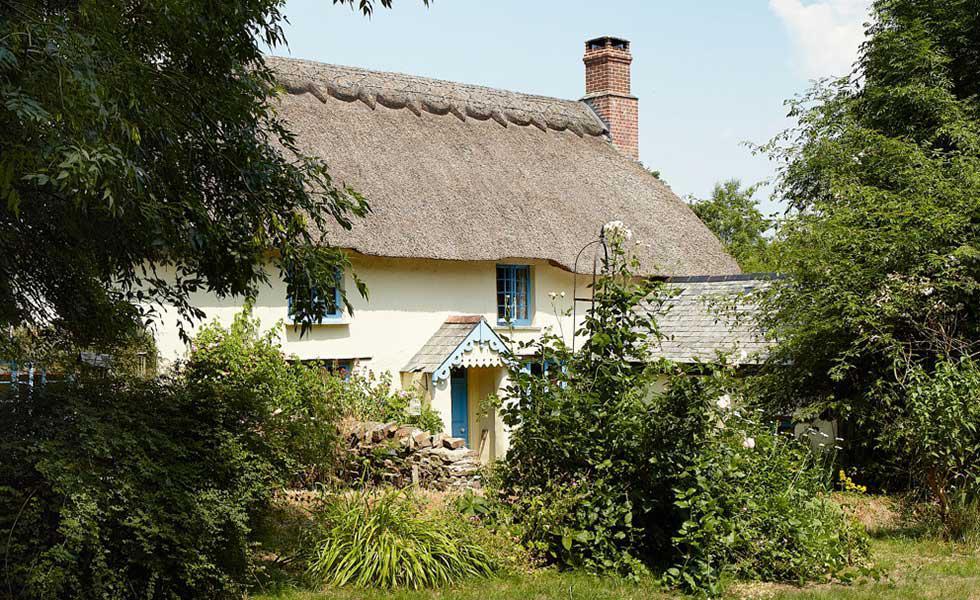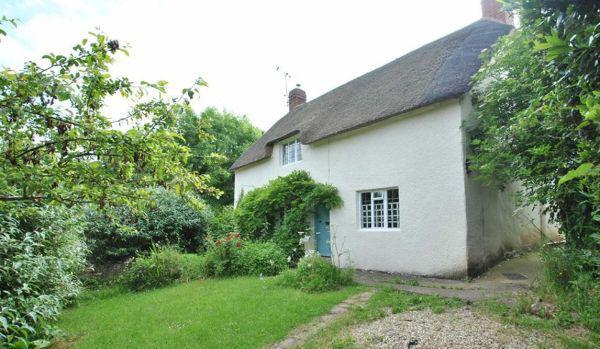The first image is the image on the left, the second image is the image on the right. Assess this claim about the two images: "On the left a green lawn rises up to meet a white country cottage.". Correct or not? Answer yes or no. No. The first image is the image on the left, the second image is the image on the right. Evaluate the accuracy of this statement regarding the images: "The left image features a white house with at least two notches in its roof to accomodate windows and a sculpted border along the top of the roof.". Is it true? Answer yes or no. No. 